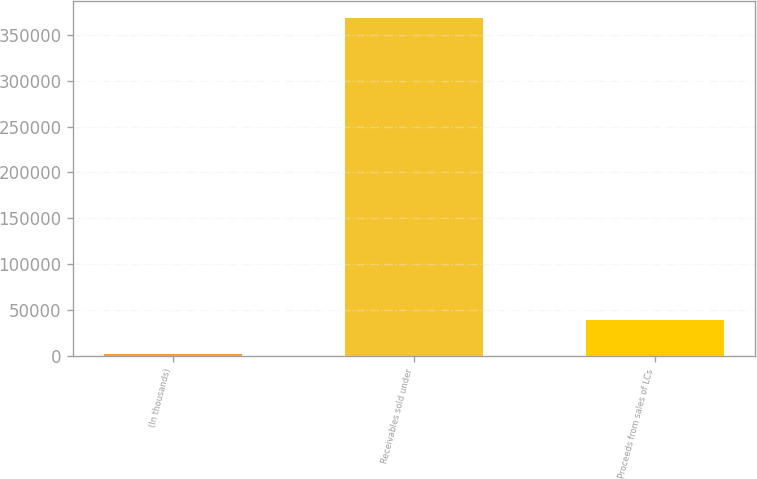<chart> <loc_0><loc_0><loc_500><loc_500><bar_chart><fcel>(In thousands)<fcel>Receivables sold under<fcel>Proceeds from sales of LCs<nl><fcel>2012<fcel>368894<fcel>38700.2<nl></chart> 